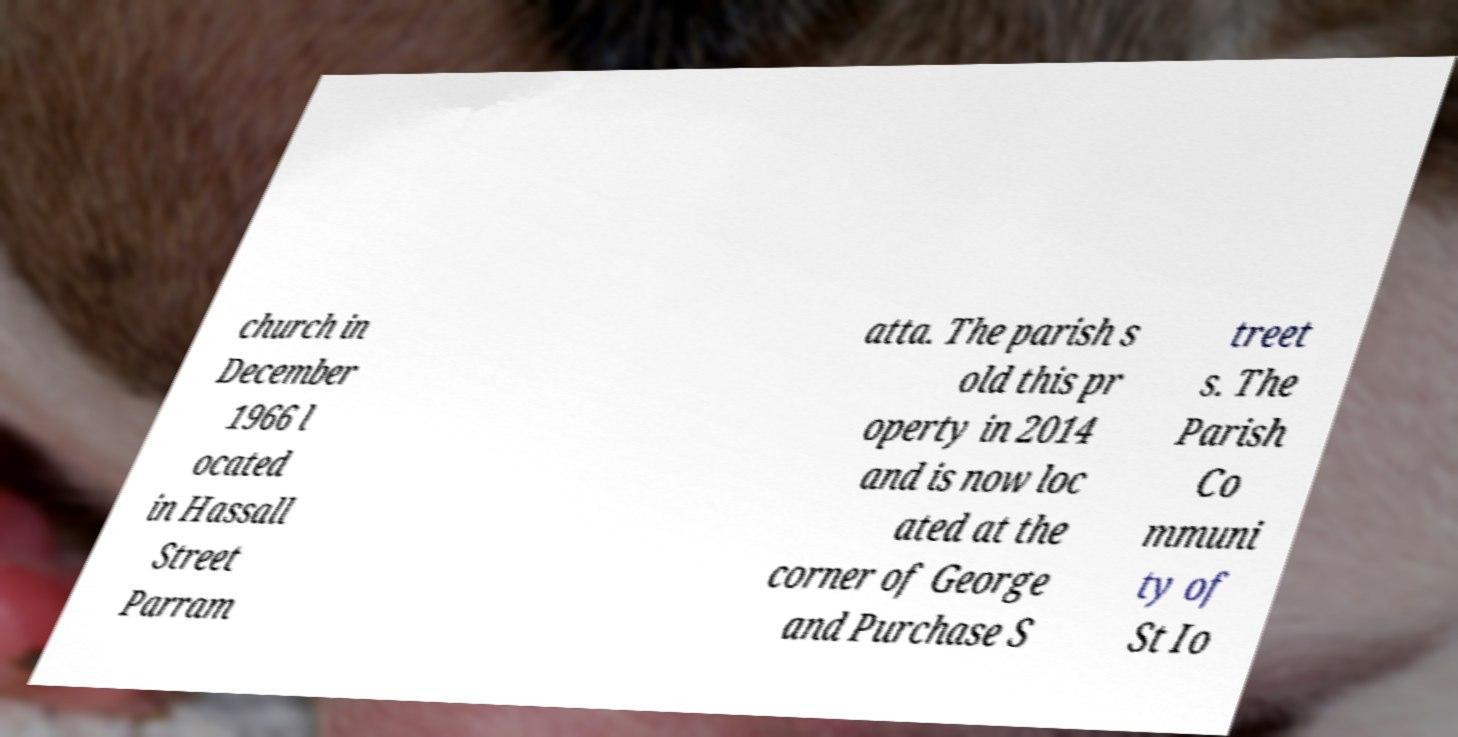Could you assist in decoding the text presented in this image and type it out clearly? church in December 1966 l ocated in Hassall Street Parram atta. The parish s old this pr operty in 2014 and is now loc ated at the corner of George and Purchase S treet s. The Parish Co mmuni ty of St Io 